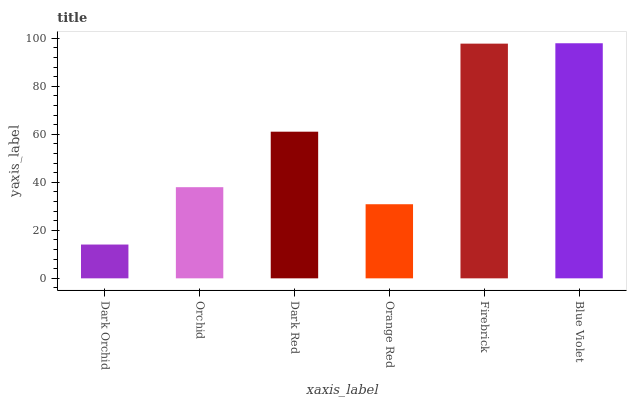Is Dark Orchid the minimum?
Answer yes or no. Yes. Is Blue Violet the maximum?
Answer yes or no. Yes. Is Orchid the minimum?
Answer yes or no. No. Is Orchid the maximum?
Answer yes or no. No. Is Orchid greater than Dark Orchid?
Answer yes or no. Yes. Is Dark Orchid less than Orchid?
Answer yes or no. Yes. Is Dark Orchid greater than Orchid?
Answer yes or no. No. Is Orchid less than Dark Orchid?
Answer yes or no. No. Is Dark Red the high median?
Answer yes or no. Yes. Is Orchid the low median?
Answer yes or no. Yes. Is Dark Orchid the high median?
Answer yes or no. No. Is Orange Red the low median?
Answer yes or no. No. 